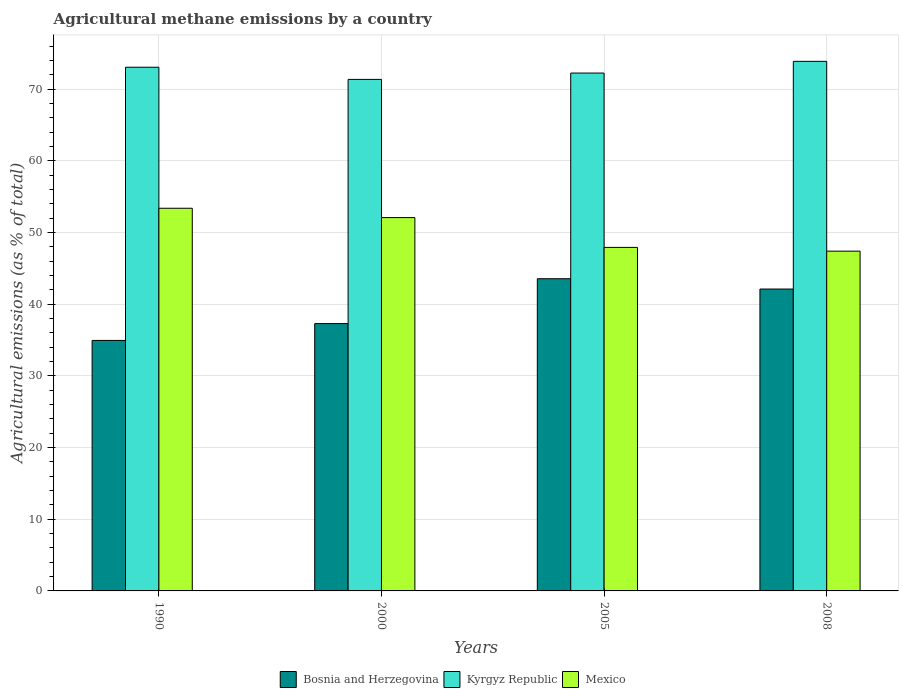How many different coloured bars are there?
Give a very brief answer. 3. How many groups of bars are there?
Give a very brief answer. 4. Are the number of bars per tick equal to the number of legend labels?
Offer a terse response. Yes. What is the label of the 2nd group of bars from the left?
Your response must be concise. 2000. In how many cases, is the number of bars for a given year not equal to the number of legend labels?
Your answer should be very brief. 0. What is the amount of agricultural methane emitted in Bosnia and Herzegovina in 2000?
Offer a terse response. 37.3. Across all years, what is the maximum amount of agricultural methane emitted in Mexico?
Your answer should be very brief. 53.39. Across all years, what is the minimum amount of agricultural methane emitted in Kyrgyz Republic?
Your answer should be compact. 71.37. What is the total amount of agricultural methane emitted in Kyrgyz Republic in the graph?
Your response must be concise. 290.59. What is the difference between the amount of agricultural methane emitted in Bosnia and Herzegovina in 2000 and that in 2008?
Ensure brevity in your answer.  -4.82. What is the difference between the amount of agricultural methane emitted in Kyrgyz Republic in 2005 and the amount of agricultural methane emitted in Bosnia and Herzegovina in 1990?
Ensure brevity in your answer.  37.3. What is the average amount of agricultural methane emitted in Bosnia and Herzegovina per year?
Give a very brief answer. 39.48. In the year 2005, what is the difference between the amount of agricultural methane emitted in Kyrgyz Republic and amount of agricultural methane emitted in Mexico?
Make the answer very short. 24.33. In how many years, is the amount of agricultural methane emitted in Mexico greater than 48 %?
Keep it short and to the point. 2. What is the ratio of the amount of agricultural methane emitted in Bosnia and Herzegovina in 1990 to that in 2008?
Give a very brief answer. 0.83. Is the amount of agricultural methane emitted in Bosnia and Herzegovina in 2000 less than that in 2008?
Keep it short and to the point. Yes. What is the difference between the highest and the second highest amount of agricultural methane emitted in Bosnia and Herzegovina?
Your answer should be very brief. 1.44. What is the difference between the highest and the lowest amount of agricultural methane emitted in Bosnia and Herzegovina?
Keep it short and to the point. 8.61. In how many years, is the amount of agricultural methane emitted in Bosnia and Herzegovina greater than the average amount of agricultural methane emitted in Bosnia and Herzegovina taken over all years?
Offer a terse response. 2. What does the 1st bar from the left in 2008 represents?
Make the answer very short. Bosnia and Herzegovina. What does the 2nd bar from the right in 2005 represents?
Your answer should be very brief. Kyrgyz Republic. How many bars are there?
Offer a very short reply. 12. Are all the bars in the graph horizontal?
Offer a terse response. No. Are the values on the major ticks of Y-axis written in scientific E-notation?
Give a very brief answer. No. Does the graph contain any zero values?
Make the answer very short. No. Where does the legend appear in the graph?
Ensure brevity in your answer.  Bottom center. How are the legend labels stacked?
Provide a succinct answer. Horizontal. What is the title of the graph?
Your answer should be very brief. Agricultural methane emissions by a country. Does "Antigua and Barbuda" appear as one of the legend labels in the graph?
Give a very brief answer. No. What is the label or title of the Y-axis?
Give a very brief answer. Agricultural emissions (as % of total). What is the Agricultural emissions (as % of total) of Bosnia and Herzegovina in 1990?
Keep it short and to the point. 34.95. What is the Agricultural emissions (as % of total) in Kyrgyz Republic in 1990?
Your response must be concise. 73.07. What is the Agricultural emissions (as % of total) in Mexico in 1990?
Keep it short and to the point. 53.39. What is the Agricultural emissions (as % of total) of Bosnia and Herzegovina in 2000?
Your response must be concise. 37.3. What is the Agricultural emissions (as % of total) of Kyrgyz Republic in 2000?
Your answer should be compact. 71.37. What is the Agricultural emissions (as % of total) of Mexico in 2000?
Keep it short and to the point. 52.09. What is the Agricultural emissions (as % of total) in Bosnia and Herzegovina in 2005?
Provide a succinct answer. 43.56. What is the Agricultural emissions (as % of total) in Kyrgyz Republic in 2005?
Give a very brief answer. 72.26. What is the Agricultural emissions (as % of total) of Mexico in 2005?
Make the answer very short. 47.93. What is the Agricultural emissions (as % of total) of Bosnia and Herzegovina in 2008?
Provide a succinct answer. 42.12. What is the Agricultural emissions (as % of total) of Kyrgyz Republic in 2008?
Your answer should be very brief. 73.89. What is the Agricultural emissions (as % of total) in Mexico in 2008?
Your answer should be very brief. 47.41. Across all years, what is the maximum Agricultural emissions (as % of total) in Bosnia and Herzegovina?
Provide a short and direct response. 43.56. Across all years, what is the maximum Agricultural emissions (as % of total) in Kyrgyz Republic?
Keep it short and to the point. 73.89. Across all years, what is the maximum Agricultural emissions (as % of total) in Mexico?
Offer a very short reply. 53.39. Across all years, what is the minimum Agricultural emissions (as % of total) in Bosnia and Herzegovina?
Keep it short and to the point. 34.95. Across all years, what is the minimum Agricultural emissions (as % of total) of Kyrgyz Republic?
Give a very brief answer. 71.37. Across all years, what is the minimum Agricultural emissions (as % of total) of Mexico?
Give a very brief answer. 47.41. What is the total Agricultural emissions (as % of total) of Bosnia and Herzegovina in the graph?
Provide a short and direct response. 157.94. What is the total Agricultural emissions (as % of total) in Kyrgyz Republic in the graph?
Give a very brief answer. 290.59. What is the total Agricultural emissions (as % of total) of Mexico in the graph?
Make the answer very short. 200.82. What is the difference between the Agricultural emissions (as % of total) of Bosnia and Herzegovina in 1990 and that in 2000?
Keep it short and to the point. -2.35. What is the difference between the Agricultural emissions (as % of total) of Kyrgyz Republic in 1990 and that in 2000?
Give a very brief answer. 1.7. What is the difference between the Agricultural emissions (as % of total) of Mexico in 1990 and that in 2000?
Your answer should be compact. 1.3. What is the difference between the Agricultural emissions (as % of total) of Bosnia and Herzegovina in 1990 and that in 2005?
Provide a succinct answer. -8.61. What is the difference between the Agricultural emissions (as % of total) of Kyrgyz Republic in 1990 and that in 2005?
Ensure brevity in your answer.  0.81. What is the difference between the Agricultural emissions (as % of total) of Mexico in 1990 and that in 2005?
Your answer should be very brief. 5.46. What is the difference between the Agricultural emissions (as % of total) in Bosnia and Herzegovina in 1990 and that in 2008?
Offer a terse response. -7.17. What is the difference between the Agricultural emissions (as % of total) of Kyrgyz Republic in 1990 and that in 2008?
Give a very brief answer. -0.82. What is the difference between the Agricultural emissions (as % of total) in Mexico in 1990 and that in 2008?
Provide a succinct answer. 5.98. What is the difference between the Agricultural emissions (as % of total) in Bosnia and Herzegovina in 2000 and that in 2005?
Give a very brief answer. -6.26. What is the difference between the Agricultural emissions (as % of total) of Kyrgyz Republic in 2000 and that in 2005?
Your answer should be very brief. -0.89. What is the difference between the Agricultural emissions (as % of total) of Mexico in 2000 and that in 2005?
Ensure brevity in your answer.  4.16. What is the difference between the Agricultural emissions (as % of total) of Bosnia and Herzegovina in 2000 and that in 2008?
Make the answer very short. -4.82. What is the difference between the Agricultural emissions (as % of total) in Kyrgyz Republic in 2000 and that in 2008?
Ensure brevity in your answer.  -2.52. What is the difference between the Agricultural emissions (as % of total) of Mexico in 2000 and that in 2008?
Offer a terse response. 4.68. What is the difference between the Agricultural emissions (as % of total) in Bosnia and Herzegovina in 2005 and that in 2008?
Offer a very short reply. 1.44. What is the difference between the Agricultural emissions (as % of total) of Kyrgyz Republic in 2005 and that in 2008?
Give a very brief answer. -1.63. What is the difference between the Agricultural emissions (as % of total) in Mexico in 2005 and that in 2008?
Your response must be concise. 0.52. What is the difference between the Agricultural emissions (as % of total) of Bosnia and Herzegovina in 1990 and the Agricultural emissions (as % of total) of Kyrgyz Republic in 2000?
Offer a terse response. -36.42. What is the difference between the Agricultural emissions (as % of total) of Bosnia and Herzegovina in 1990 and the Agricultural emissions (as % of total) of Mexico in 2000?
Provide a succinct answer. -17.14. What is the difference between the Agricultural emissions (as % of total) in Kyrgyz Republic in 1990 and the Agricultural emissions (as % of total) in Mexico in 2000?
Your answer should be compact. 20.98. What is the difference between the Agricultural emissions (as % of total) in Bosnia and Herzegovina in 1990 and the Agricultural emissions (as % of total) in Kyrgyz Republic in 2005?
Your response must be concise. -37.3. What is the difference between the Agricultural emissions (as % of total) in Bosnia and Herzegovina in 1990 and the Agricultural emissions (as % of total) in Mexico in 2005?
Make the answer very short. -12.98. What is the difference between the Agricultural emissions (as % of total) of Kyrgyz Republic in 1990 and the Agricultural emissions (as % of total) of Mexico in 2005?
Give a very brief answer. 25.14. What is the difference between the Agricultural emissions (as % of total) of Bosnia and Herzegovina in 1990 and the Agricultural emissions (as % of total) of Kyrgyz Republic in 2008?
Offer a very short reply. -38.94. What is the difference between the Agricultural emissions (as % of total) of Bosnia and Herzegovina in 1990 and the Agricultural emissions (as % of total) of Mexico in 2008?
Keep it short and to the point. -12.45. What is the difference between the Agricultural emissions (as % of total) of Kyrgyz Republic in 1990 and the Agricultural emissions (as % of total) of Mexico in 2008?
Your answer should be very brief. 25.66. What is the difference between the Agricultural emissions (as % of total) in Bosnia and Herzegovina in 2000 and the Agricultural emissions (as % of total) in Kyrgyz Republic in 2005?
Your answer should be very brief. -34.96. What is the difference between the Agricultural emissions (as % of total) in Bosnia and Herzegovina in 2000 and the Agricultural emissions (as % of total) in Mexico in 2005?
Keep it short and to the point. -10.63. What is the difference between the Agricultural emissions (as % of total) in Kyrgyz Republic in 2000 and the Agricultural emissions (as % of total) in Mexico in 2005?
Offer a very short reply. 23.44. What is the difference between the Agricultural emissions (as % of total) in Bosnia and Herzegovina in 2000 and the Agricultural emissions (as % of total) in Kyrgyz Republic in 2008?
Provide a short and direct response. -36.59. What is the difference between the Agricultural emissions (as % of total) of Bosnia and Herzegovina in 2000 and the Agricultural emissions (as % of total) of Mexico in 2008?
Keep it short and to the point. -10.11. What is the difference between the Agricultural emissions (as % of total) of Kyrgyz Republic in 2000 and the Agricultural emissions (as % of total) of Mexico in 2008?
Ensure brevity in your answer.  23.96. What is the difference between the Agricultural emissions (as % of total) of Bosnia and Herzegovina in 2005 and the Agricultural emissions (as % of total) of Kyrgyz Republic in 2008?
Provide a succinct answer. -30.33. What is the difference between the Agricultural emissions (as % of total) of Bosnia and Herzegovina in 2005 and the Agricultural emissions (as % of total) of Mexico in 2008?
Offer a very short reply. -3.85. What is the difference between the Agricultural emissions (as % of total) of Kyrgyz Republic in 2005 and the Agricultural emissions (as % of total) of Mexico in 2008?
Your response must be concise. 24.85. What is the average Agricultural emissions (as % of total) in Bosnia and Herzegovina per year?
Provide a short and direct response. 39.48. What is the average Agricultural emissions (as % of total) of Kyrgyz Republic per year?
Your response must be concise. 72.65. What is the average Agricultural emissions (as % of total) in Mexico per year?
Give a very brief answer. 50.21. In the year 1990, what is the difference between the Agricultural emissions (as % of total) of Bosnia and Herzegovina and Agricultural emissions (as % of total) of Kyrgyz Republic?
Your answer should be compact. -38.12. In the year 1990, what is the difference between the Agricultural emissions (as % of total) in Bosnia and Herzegovina and Agricultural emissions (as % of total) in Mexico?
Ensure brevity in your answer.  -18.44. In the year 1990, what is the difference between the Agricultural emissions (as % of total) of Kyrgyz Republic and Agricultural emissions (as % of total) of Mexico?
Give a very brief answer. 19.68. In the year 2000, what is the difference between the Agricultural emissions (as % of total) of Bosnia and Herzegovina and Agricultural emissions (as % of total) of Kyrgyz Republic?
Your answer should be very brief. -34.07. In the year 2000, what is the difference between the Agricultural emissions (as % of total) in Bosnia and Herzegovina and Agricultural emissions (as % of total) in Mexico?
Offer a terse response. -14.79. In the year 2000, what is the difference between the Agricultural emissions (as % of total) in Kyrgyz Republic and Agricultural emissions (as % of total) in Mexico?
Offer a very short reply. 19.28. In the year 2005, what is the difference between the Agricultural emissions (as % of total) in Bosnia and Herzegovina and Agricultural emissions (as % of total) in Kyrgyz Republic?
Make the answer very short. -28.7. In the year 2005, what is the difference between the Agricultural emissions (as % of total) in Bosnia and Herzegovina and Agricultural emissions (as % of total) in Mexico?
Ensure brevity in your answer.  -4.37. In the year 2005, what is the difference between the Agricultural emissions (as % of total) of Kyrgyz Republic and Agricultural emissions (as % of total) of Mexico?
Provide a short and direct response. 24.33. In the year 2008, what is the difference between the Agricultural emissions (as % of total) in Bosnia and Herzegovina and Agricultural emissions (as % of total) in Kyrgyz Republic?
Give a very brief answer. -31.77. In the year 2008, what is the difference between the Agricultural emissions (as % of total) in Bosnia and Herzegovina and Agricultural emissions (as % of total) in Mexico?
Give a very brief answer. -5.29. In the year 2008, what is the difference between the Agricultural emissions (as % of total) in Kyrgyz Republic and Agricultural emissions (as % of total) in Mexico?
Keep it short and to the point. 26.48. What is the ratio of the Agricultural emissions (as % of total) of Bosnia and Herzegovina in 1990 to that in 2000?
Offer a very short reply. 0.94. What is the ratio of the Agricultural emissions (as % of total) in Kyrgyz Republic in 1990 to that in 2000?
Provide a short and direct response. 1.02. What is the ratio of the Agricultural emissions (as % of total) of Mexico in 1990 to that in 2000?
Offer a very short reply. 1.02. What is the ratio of the Agricultural emissions (as % of total) in Bosnia and Herzegovina in 1990 to that in 2005?
Provide a succinct answer. 0.8. What is the ratio of the Agricultural emissions (as % of total) in Kyrgyz Republic in 1990 to that in 2005?
Your answer should be compact. 1.01. What is the ratio of the Agricultural emissions (as % of total) in Mexico in 1990 to that in 2005?
Provide a succinct answer. 1.11. What is the ratio of the Agricultural emissions (as % of total) of Bosnia and Herzegovina in 1990 to that in 2008?
Your response must be concise. 0.83. What is the ratio of the Agricultural emissions (as % of total) of Kyrgyz Republic in 1990 to that in 2008?
Your answer should be compact. 0.99. What is the ratio of the Agricultural emissions (as % of total) in Mexico in 1990 to that in 2008?
Provide a succinct answer. 1.13. What is the ratio of the Agricultural emissions (as % of total) in Bosnia and Herzegovina in 2000 to that in 2005?
Provide a succinct answer. 0.86. What is the ratio of the Agricultural emissions (as % of total) in Mexico in 2000 to that in 2005?
Provide a succinct answer. 1.09. What is the ratio of the Agricultural emissions (as % of total) in Bosnia and Herzegovina in 2000 to that in 2008?
Provide a succinct answer. 0.89. What is the ratio of the Agricultural emissions (as % of total) of Kyrgyz Republic in 2000 to that in 2008?
Give a very brief answer. 0.97. What is the ratio of the Agricultural emissions (as % of total) in Mexico in 2000 to that in 2008?
Give a very brief answer. 1.1. What is the ratio of the Agricultural emissions (as % of total) in Bosnia and Herzegovina in 2005 to that in 2008?
Make the answer very short. 1.03. What is the ratio of the Agricultural emissions (as % of total) of Kyrgyz Republic in 2005 to that in 2008?
Your answer should be very brief. 0.98. What is the ratio of the Agricultural emissions (as % of total) in Mexico in 2005 to that in 2008?
Provide a short and direct response. 1.01. What is the difference between the highest and the second highest Agricultural emissions (as % of total) of Bosnia and Herzegovina?
Ensure brevity in your answer.  1.44. What is the difference between the highest and the second highest Agricultural emissions (as % of total) in Kyrgyz Republic?
Your answer should be very brief. 0.82. What is the difference between the highest and the second highest Agricultural emissions (as % of total) of Mexico?
Provide a succinct answer. 1.3. What is the difference between the highest and the lowest Agricultural emissions (as % of total) in Bosnia and Herzegovina?
Give a very brief answer. 8.61. What is the difference between the highest and the lowest Agricultural emissions (as % of total) in Kyrgyz Republic?
Give a very brief answer. 2.52. What is the difference between the highest and the lowest Agricultural emissions (as % of total) of Mexico?
Ensure brevity in your answer.  5.98. 